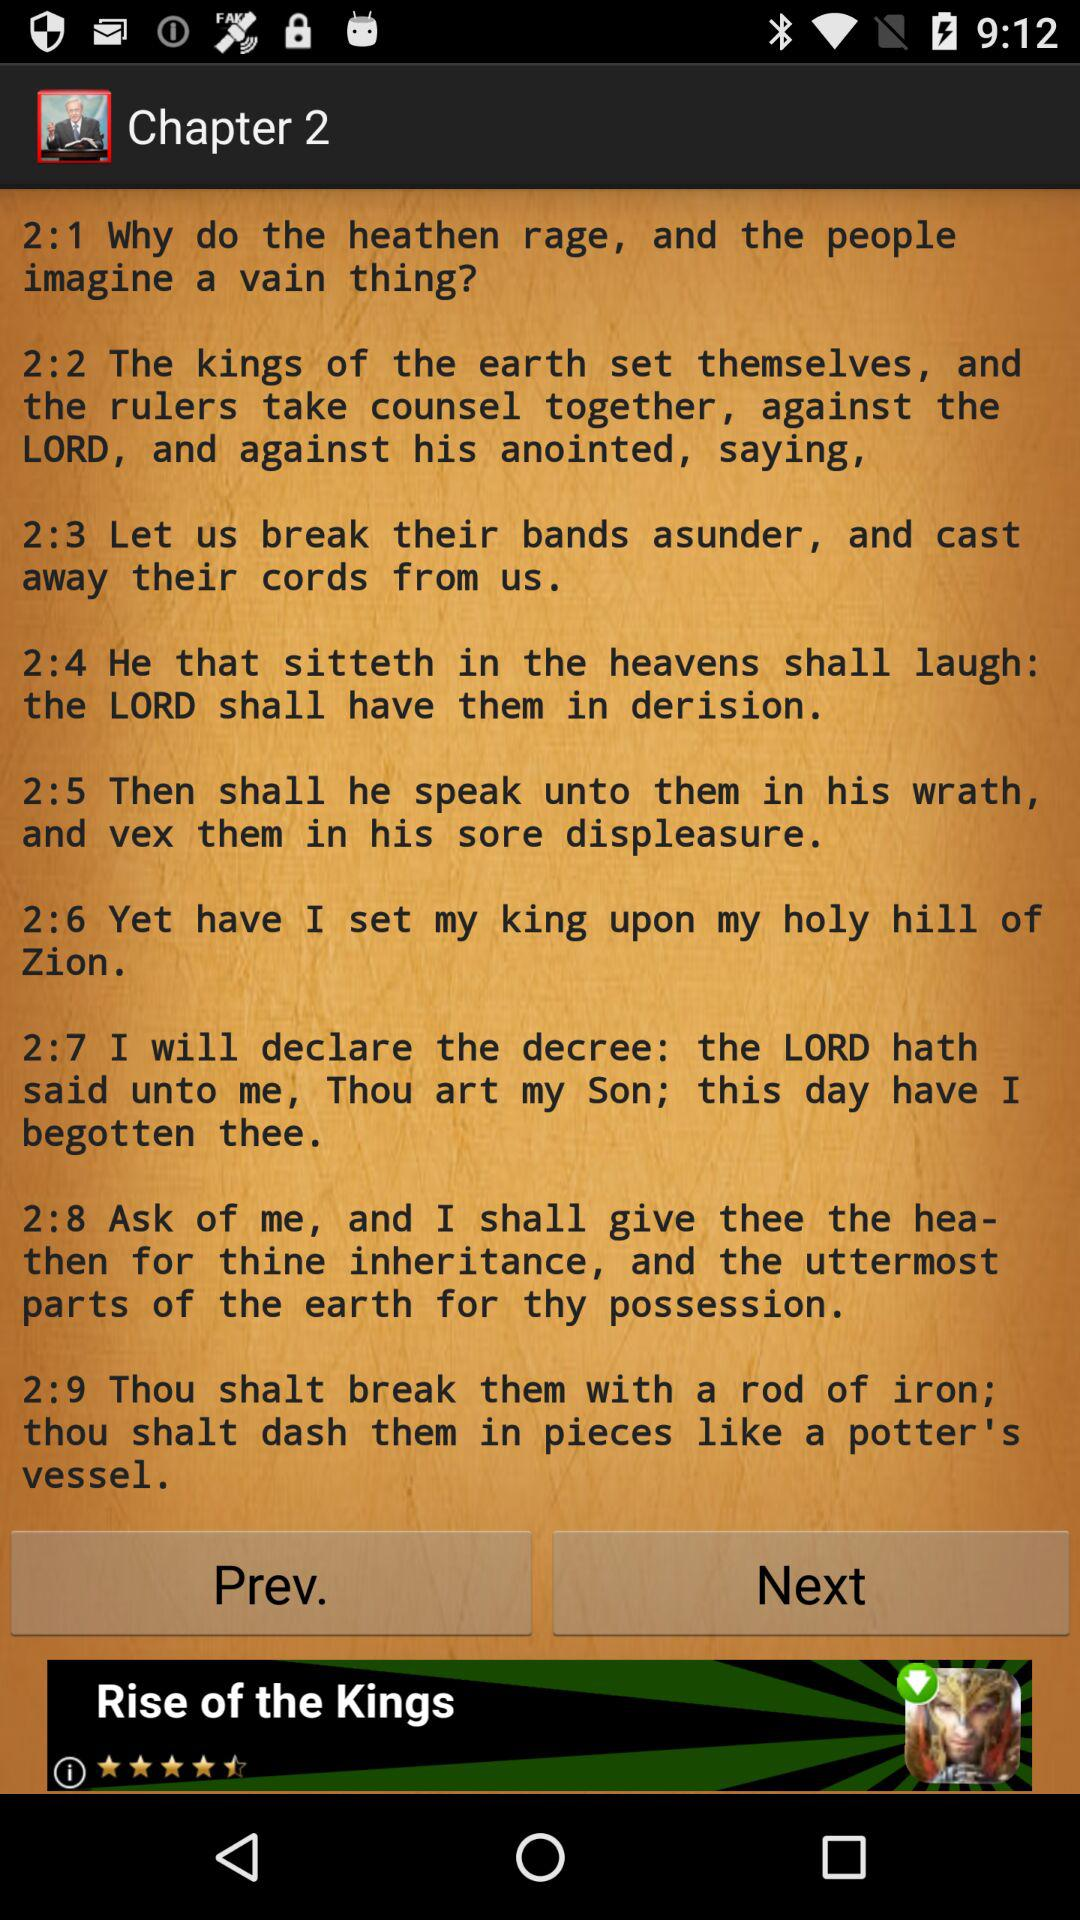How many verses are there in the chapter?
Answer the question using a single word or phrase. 9 